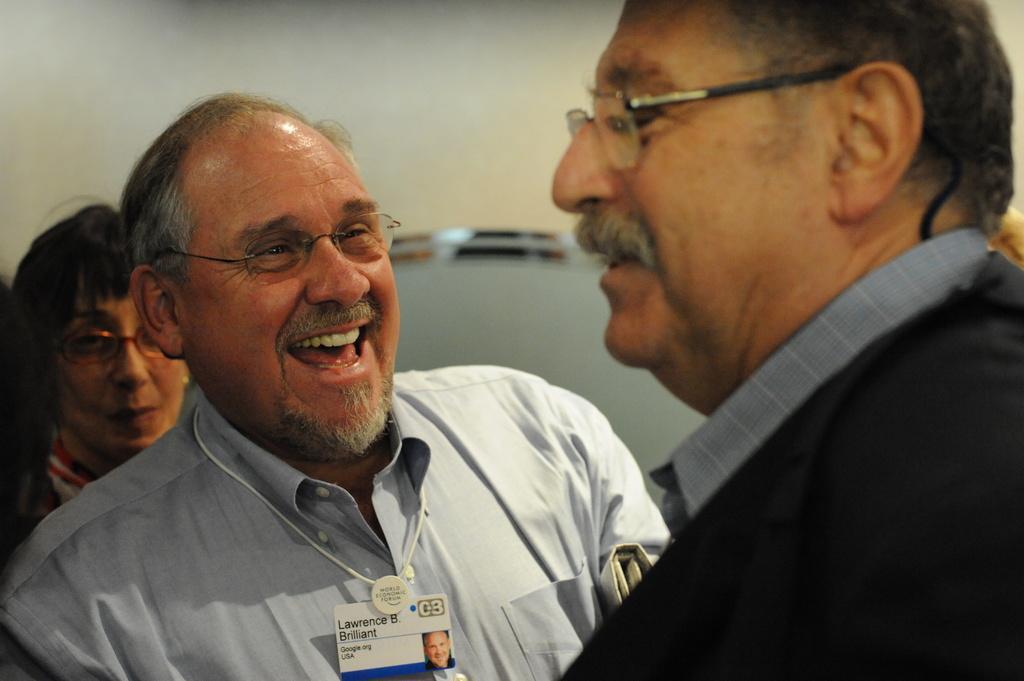In one or two sentences, can you explain what this image depicts? In this image I can see three persons and I can see all of them are wearing specs. I can also see the middle one is wearing an ID card and I can also see smile on his face. I can see this image is little bit blurry in the background. 